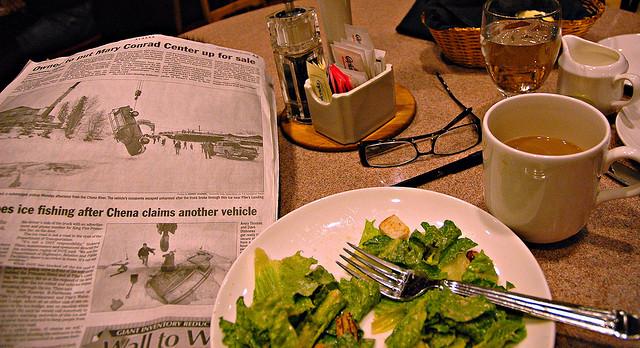What reading material is on the table?
Answer briefly. Newspaper. What utensil is on the plate?
Answer briefly. Fork. Do you find meat in the salad?
Give a very brief answer. No. 